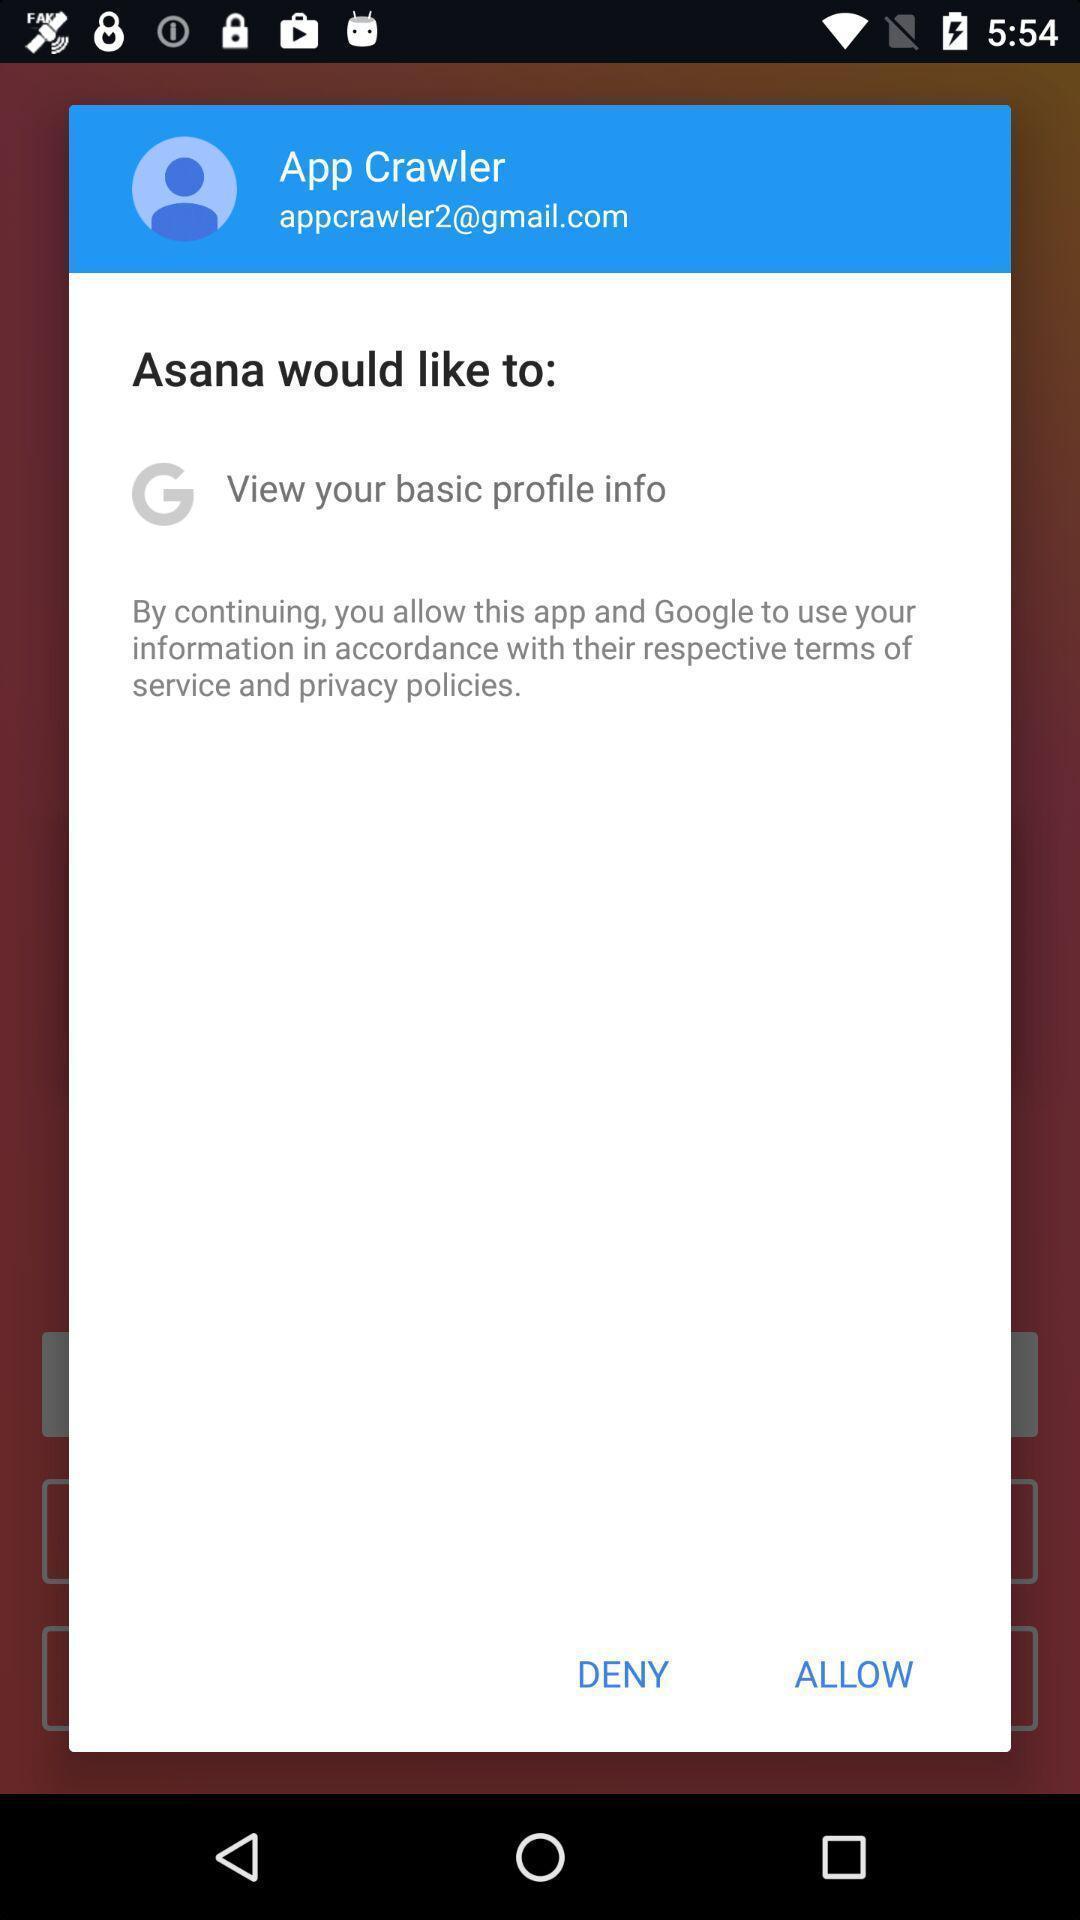Explain what's happening in this screen capture. Pop-up shows to continue with social app. 